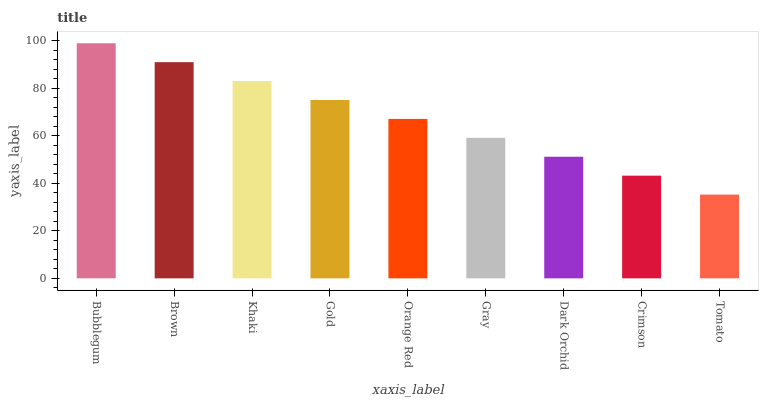Is Tomato the minimum?
Answer yes or no. Yes. Is Bubblegum the maximum?
Answer yes or no. Yes. Is Brown the minimum?
Answer yes or no. No. Is Brown the maximum?
Answer yes or no. No. Is Bubblegum greater than Brown?
Answer yes or no. Yes. Is Brown less than Bubblegum?
Answer yes or no. Yes. Is Brown greater than Bubblegum?
Answer yes or no. No. Is Bubblegum less than Brown?
Answer yes or no. No. Is Orange Red the high median?
Answer yes or no. Yes. Is Orange Red the low median?
Answer yes or no. Yes. Is Khaki the high median?
Answer yes or no. No. Is Gray the low median?
Answer yes or no. No. 